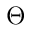Convert formula to latex. <formula><loc_0><loc_0><loc_500><loc_500>\Theta</formula> 